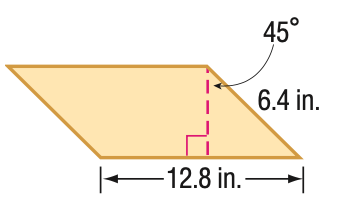Question: Find the area of the parallelogram. Round to the nearest tenth if necessary.
Choices:
A. 41.0
B. 57.9
C. 70.9
D. 81.9
Answer with the letter. Answer: B 